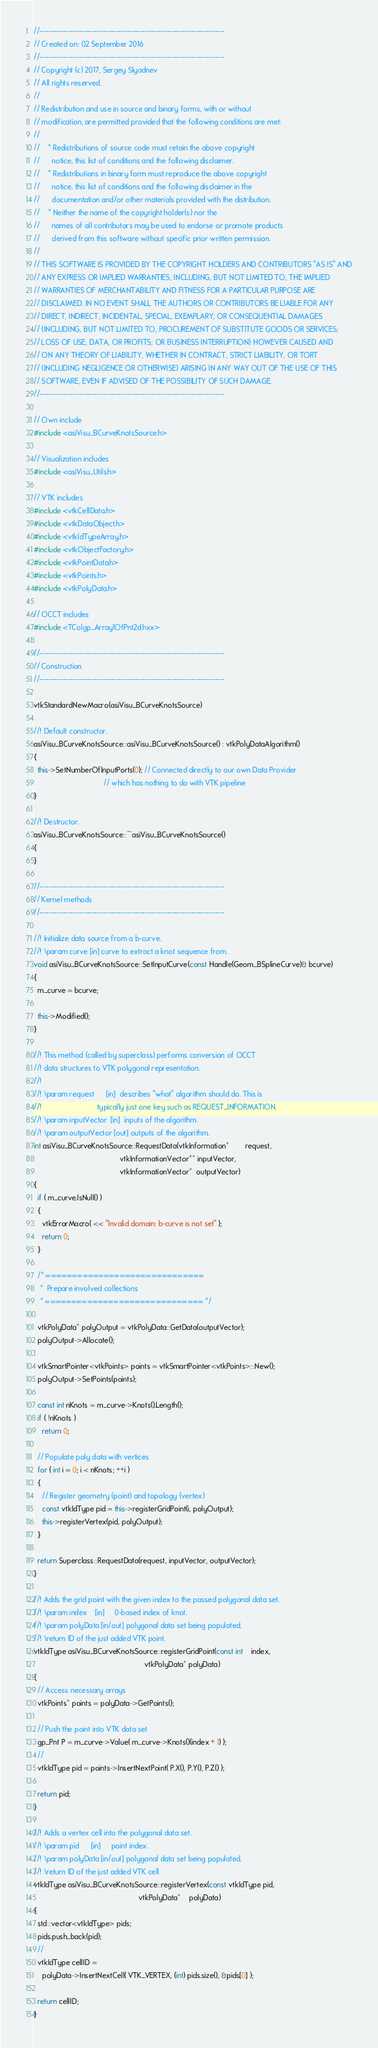Convert code to text. <code><loc_0><loc_0><loc_500><loc_500><_C++_>//-----------------------------------------------------------------------------
// Created on: 02 September 2016
//-----------------------------------------------------------------------------
// Copyright (c) 2017, Sergey Slyadnev
// All rights reserved.
//
// Redistribution and use in source and binary forms, with or without
// modification, are permitted provided that the following conditions are met:
//
//    * Redistributions of source code must retain the above copyright
//      notice, this list of conditions and the following disclaimer.
//    * Redistributions in binary form must reproduce the above copyright
//      notice, this list of conditions and the following disclaimer in the
//      documentation and/or other materials provided with the distribution.
//    * Neither the name of the copyright holder(s) nor the
//      names of all contributors may be used to endorse or promote products
//      derived from this software without specific prior written permission.
//
// THIS SOFTWARE IS PROVIDED BY THE COPYRIGHT HOLDERS AND CONTRIBUTORS "AS IS" AND
// ANY EXPRESS OR IMPLIED WARRANTIES, INCLUDING, BUT NOT LIMITED TO, THE IMPLIED
// WARRANTIES OF MERCHANTABILITY AND FITNESS FOR A PARTICULAR PURPOSE ARE
// DISCLAIMED. IN NO EVENT SHALL THE AUTHORS OR CONTRIBUTORS BE LIABLE FOR ANY
// DIRECT, INDIRECT, INCIDENTAL, SPECIAL, EXEMPLARY, OR CONSEQUENTIAL DAMAGES
// (INCLUDING, BUT NOT LIMITED TO, PROCUREMENT OF SUBSTITUTE GOODS OR SERVICES;
// LOSS OF USE, DATA, OR PROFITS; OR BUSINESS INTERRUPTION) HOWEVER CAUSED AND
// ON ANY THEORY OF LIABILITY, WHETHER IN CONTRACT, STRICT LIABILITY, OR TORT
// (INCLUDING NEGLIGENCE OR OTHERWISE) ARISING IN ANY WAY OUT OF THE USE OF THIS
// SOFTWARE, EVEN IF ADVISED OF THE POSSIBILITY OF SUCH DAMAGE.
//-----------------------------------------------------------------------------

// Own include
#include <asiVisu_BCurveKnotsSource.h>

// Visualization includes
#include <asiVisu_Utils.h>

// VTK includes
#include <vtkCellData.h>
#include <vtkDataObject.h>
#include <vtkIdTypeArray.h>
#include <vtkObjectFactory.h>
#include <vtkPointData.h>
#include <vtkPoints.h>
#include <vtkPolyData.h>

// OCCT includes
#include <TColgp_Array1OfPnt2d.hxx>

//-----------------------------------------------------------------------------
// Construction
//-----------------------------------------------------------------------------

vtkStandardNewMacro(asiVisu_BCurveKnotsSource)

//! Default constructor.
asiVisu_BCurveKnotsSource::asiVisu_BCurveKnotsSource() : vtkPolyDataAlgorithm()
{
  this->SetNumberOfInputPorts(0); // Connected directly to our own Data Provider
                                  // which has nothing to do with VTK pipeline
}

//! Destructor.
asiVisu_BCurveKnotsSource::~asiVisu_BCurveKnotsSource()
{
}

//-----------------------------------------------------------------------------
// Kernel methods
//-----------------------------------------------------------------------------

//! Initialize data source from a b-curve.
//! \param curve [in] curve to extract a knot sequence from.
void asiVisu_BCurveKnotsSource::SetInputCurve(const Handle(Geom_BSplineCurve)& bcurve)
{
  m_curve = bcurve;

  this->Modified();
}

//! This method (called by superclass) performs conversion of OCCT
//! data structures to VTK polygonal representation.
//!
//! \param request      [in]  describes "what" algorithm should do. This is
//!                           typically just one key such as REQUEST_INFORMATION.
//! \param inputVector  [in]  inputs of the algorithm.
//! \param outputVector [out] outputs of the algorithm.
int asiVisu_BCurveKnotsSource::RequestData(vtkInformation*        request,
                                          vtkInformationVector** inputVector,
                                          vtkInformationVector*  outputVector)
{
  if ( m_curve.IsNull() )
  {
    vtkErrorMacro( << "Invalid domain: b-curve is not set" );
    return 0;
  }

  /* ==============================
   *  Prepare involved collections
   * ============================== */

  vtkPolyData* polyOutput = vtkPolyData::GetData(outputVector);
  polyOutput->Allocate();

  vtkSmartPointer<vtkPoints> points = vtkSmartPointer<vtkPoints>::New();
  polyOutput->SetPoints(points);

  const int nKnots = m_curve->Knots().Length();
  if ( !nKnots )
    return 0;

  // Populate poly data with vertices
  for ( int i = 0; i < nKnots; ++i )
  {
    // Register geometry (point) and topology (vertex)
    const vtkIdType pid = this->registerGridPoint(i, polyOutput);
    this->registerVertex(pid, polyOutput);
  }

  return Superclass::RequestData(request, inputVector, outputVector);
}

//! Adds the grid point with the given index to the passed polygonal data set.
//! \param index    [in]     0-based index of knot.
//! \param polyData [in/out] polygonal data set being populated.
//! \return ID of the just added VTK point.
vtkIdType asiVisu_BCurveKnotsSource::registerGridPoint(const int    index,
                                                      vtkPolyData* polyData)
{
  // Access necessary arrays
  vtkPoints* points = polyData->GetPoints();

  // Push the point into VTK data set
  gp_Pnt P = m_curve->Value( m_curve->Knots()(index + 1) );
  //
  vtkIdType pid = points->InsertNextPoint( P.X(), P.Y(), P.Z() );

  return pid;
}

//! Adds a vertex cell into the polygonal data set.
//! \param pid      [in]     point index.
//! \param polyData [in/out] polygonal data set being populated.
//! \return ID of the just added VTK cell.
vtkIdType asiVisu_BCurveKnotsSource::registerVertex(const vtkIdType pid,
                                                   vtkPolyData*    polyData)
{
  std::vector<vtkIdType> pids;
  pids.push_back(pid);
  //
  vtkIdType cellID =
    polyData->InsertNextCell( VTK_VERTEX, (int) pids.size(), &pids[0] );

  return cellID;
}
</code> 